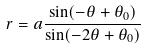<formula> <loc_0><loc_0><loc_500><loc_500>r = a \frac { \sin ( - \theta + \theta _ { 0 } ) } { \sin ( - 2 \theta + \theta _ { 0 } ) }</formula> 